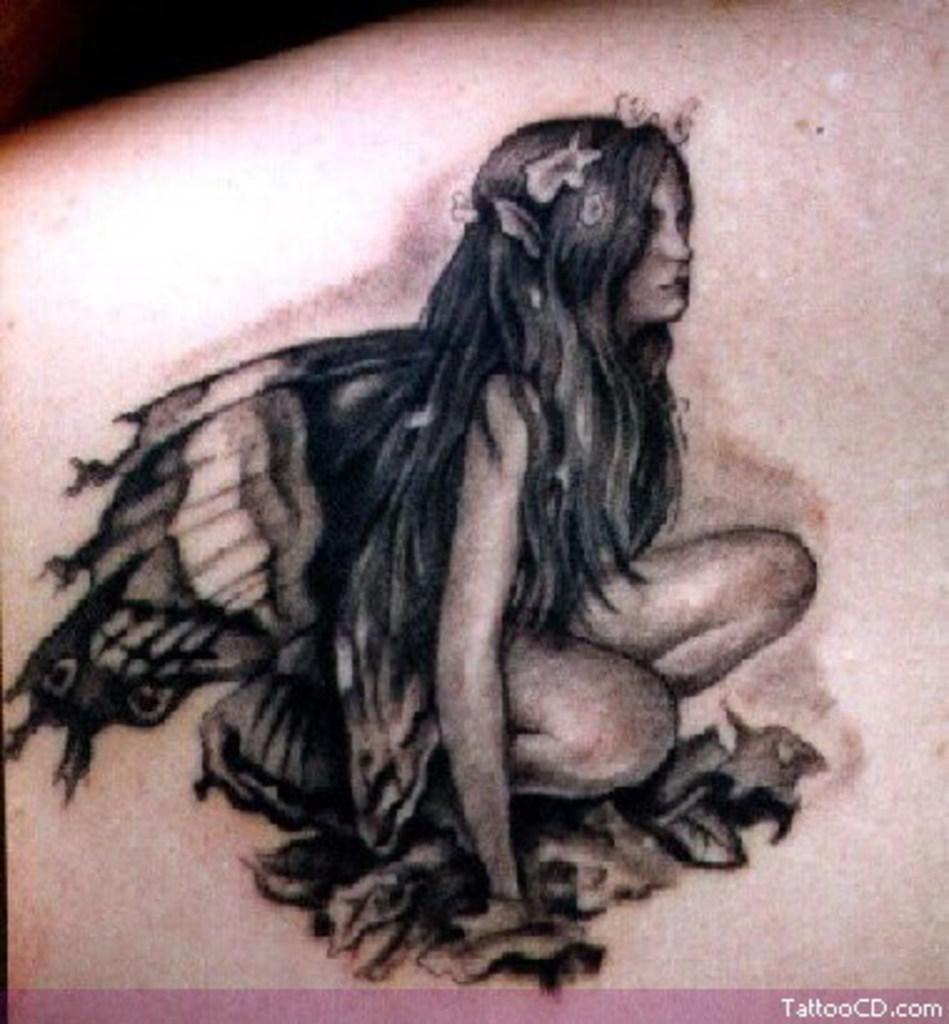What is visible on the skin in the image? There is a tattoo on the skin in the image. What does the tattoo depict? The tattoo depicts a woman with wings. Is there any additional information or marking in the image? Yes, there is a watermark at the bottom of the image. How many trees are visible in the image? There are no trees visible in the image; it features a tattoo on the skin. What type of fruit is the woman holding in the tattoo? The tattoo depicts a woman with wings, but there is no fruit present in the image. 